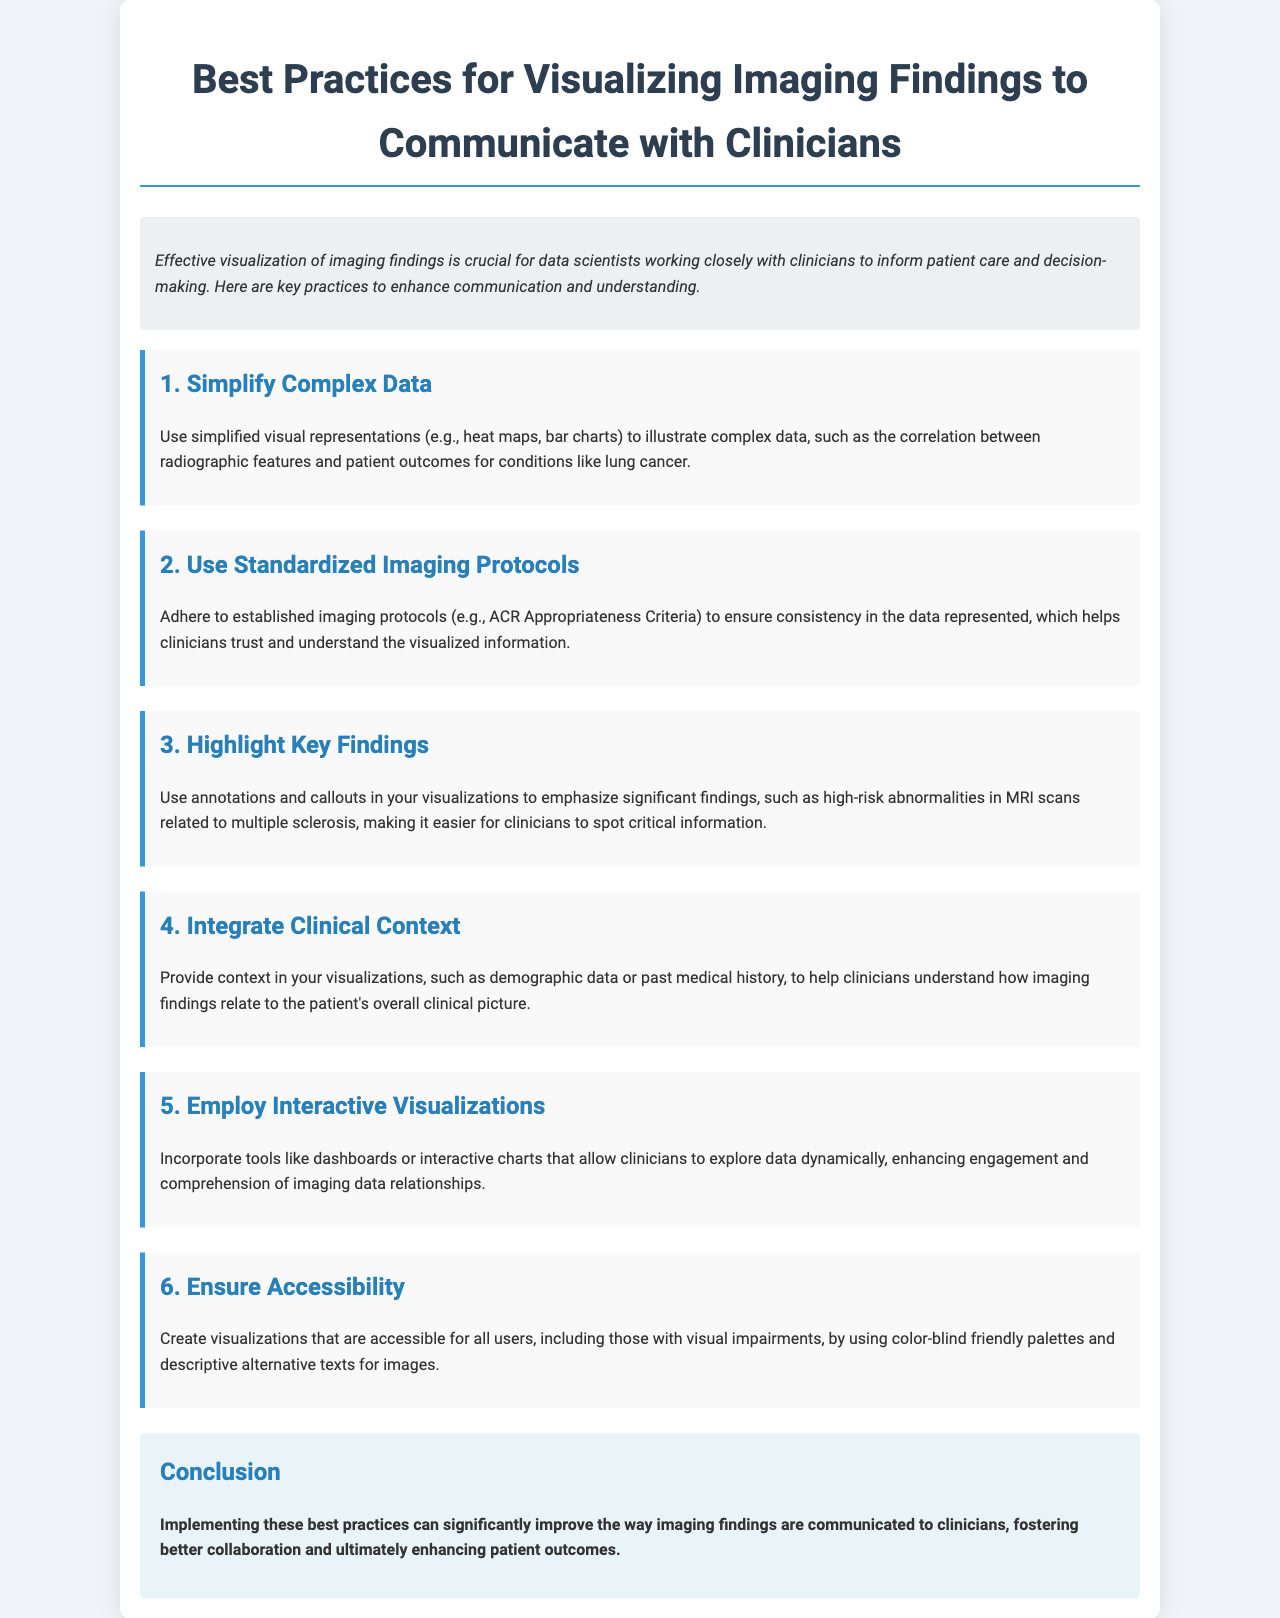What is the main topic of the brochure? The main topic is about enhancing visualization practices for better communication with clinicians regarding imaging findings.
Answer: Best Practices for Visualizing Imaging Findings How many sections are listed in the document? The document contains six sections detailing different best practices for visualization.
Answer: 6 What is recommended to simplify complex data? The document suggests using simplified visual representations such as heat maps and bar charts.
Answer: Simplified visual representations What is emphasized in visualizations for high-risk abnormalities? The document emphasizes using annotations and callouts to highlight significant findings.
Answer: Annotations and callouts What is an example of a standardized imaging protocol mentioned? The document mentions the ACR Appropriateness Criteria as an established imaging protocol.
Answer: ACR Appropriateness Criteria What is the conclusion of the document? The conclusion states that implementing best practices can enhance collaboration and patient outcomes.
Answer: Better collaboration and enhanced patient outcomes 